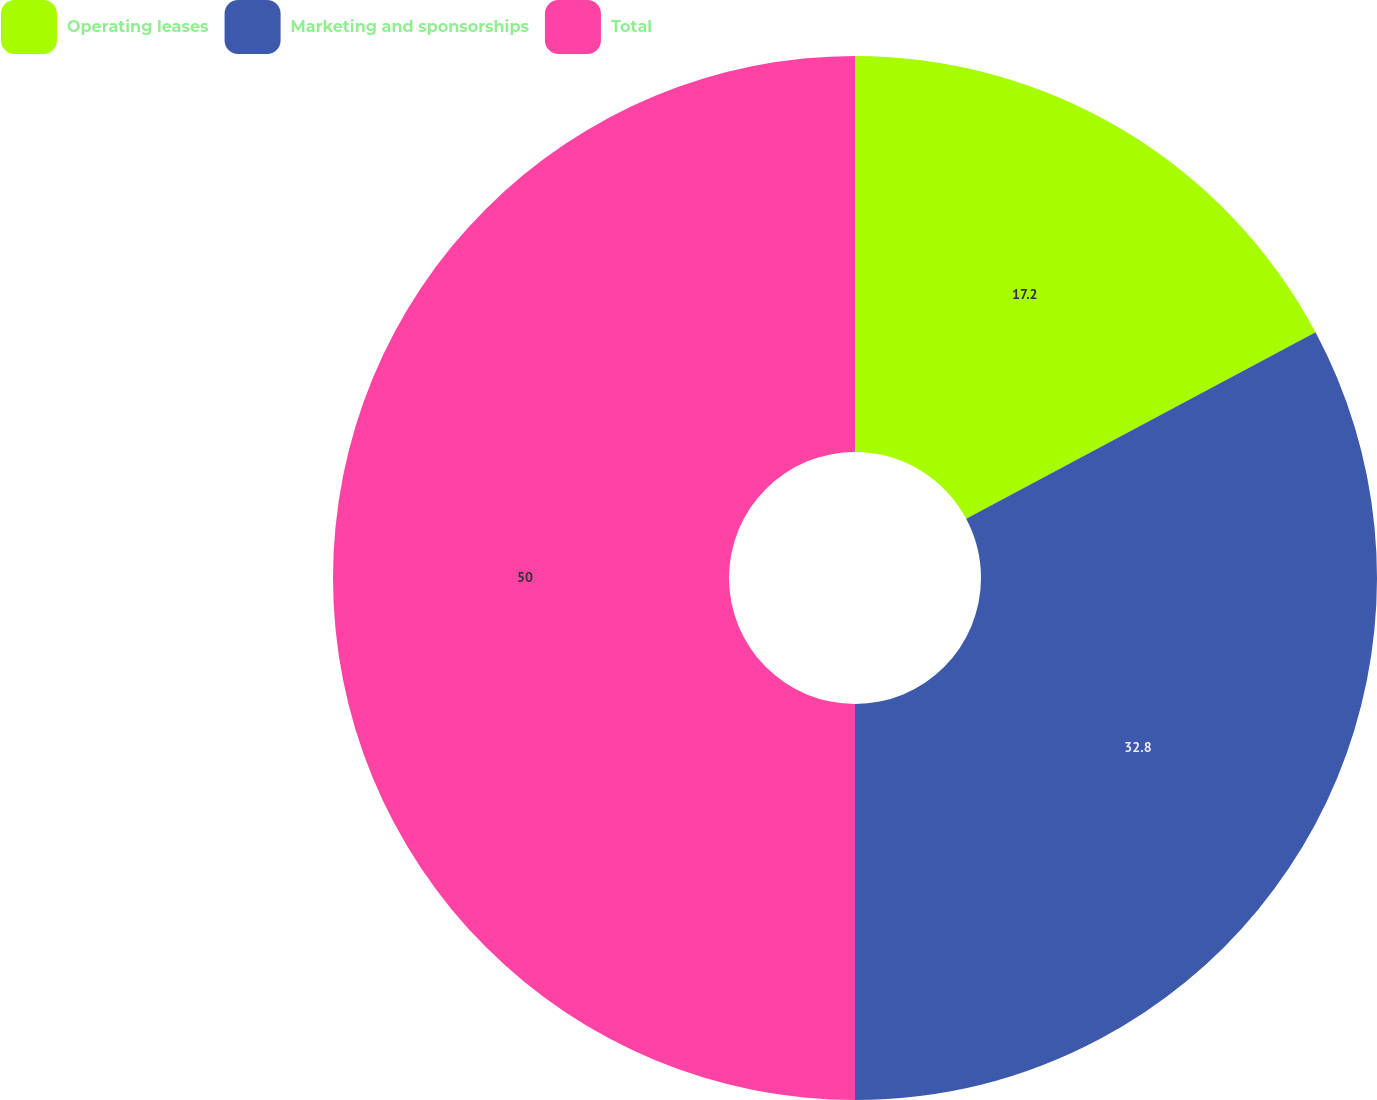Convert chart. <chart><loc_0><loc_0><loc_500><loc_500><pie_chart><fcel>Operating leases<fcel>Marketing and sponsorships<fcel>Total<nl><fcel>17.2%<fcel>32.8%<fcel>50.0%<nl></chart> 